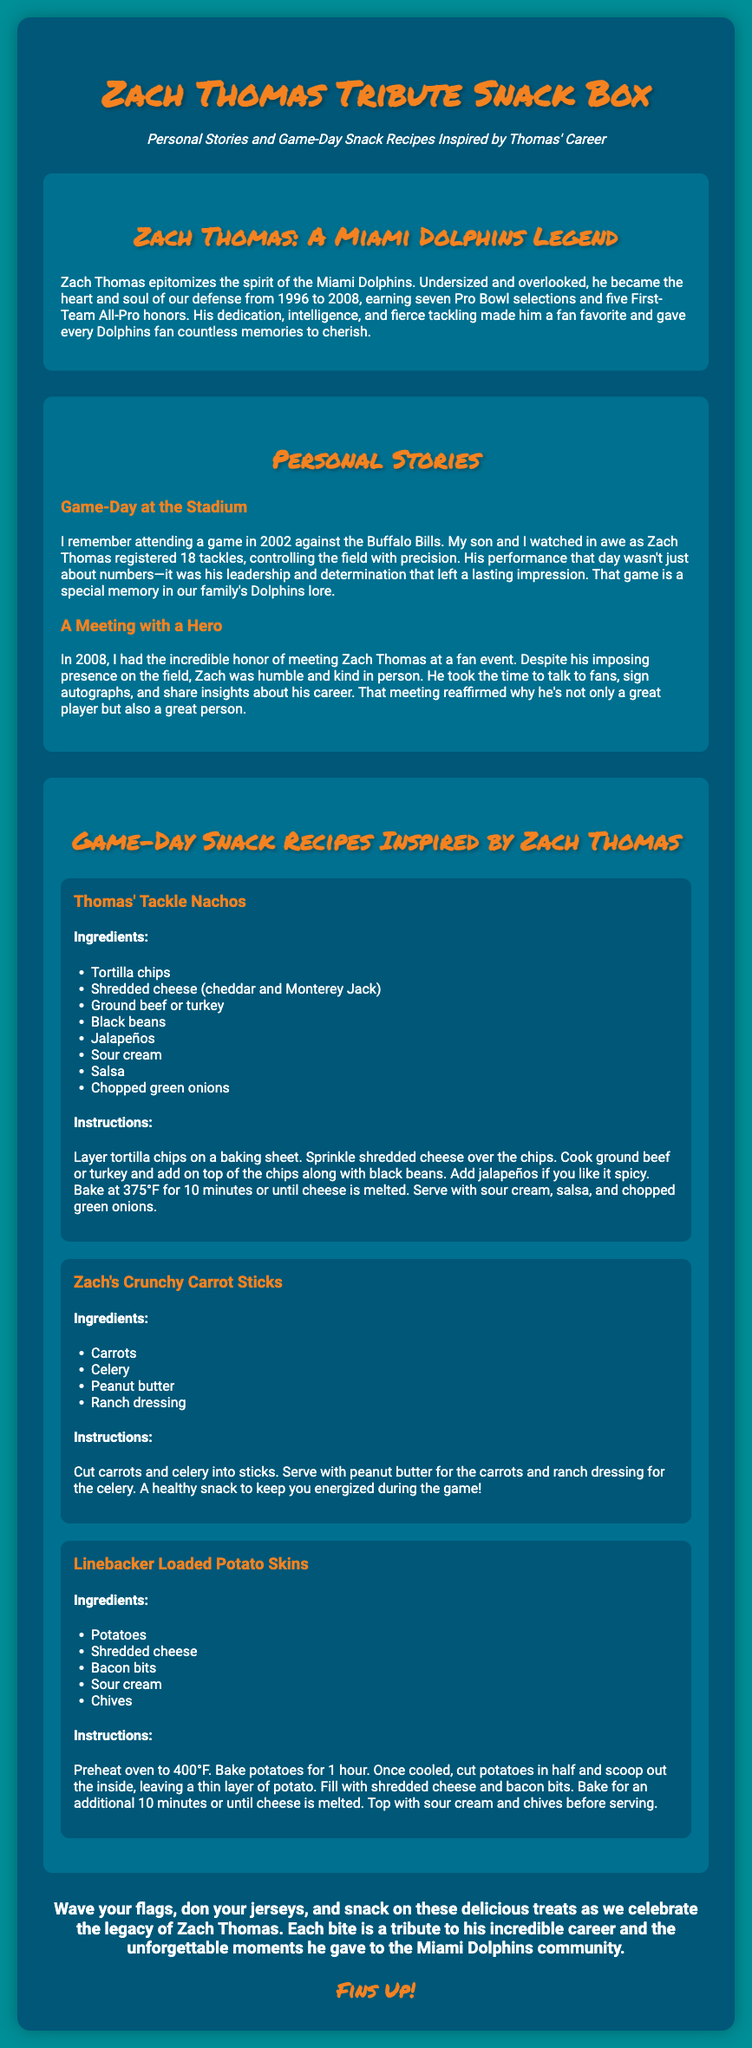What years did Zach Thomas play for the Miami Dolphins? Zach Thomas played for the Miami Dolphins from 1996 to 2008.
Answer: 1996 to 2008 How many Pro Bowl selections did Zach Thomas earn? Zach Thomas earned seven Pro Bowl selections as stated in the document.
Answer: Seven What is the title of the first snack recipe? The title of the first snack recipe mentioned in the document is "Thomas' Tackle Nachos."
Answer: Thomas' Tackle Nachos What memorable game event is described in the personal stories section? The memorable game event described is a game against the Buffalo Bills in 2002 where Zach Thomas registered 18 tackles.
Answer: Game against the Buffalo Bills in 2002 What healthy snack is featured in the snack recipes? The healthy snack featured in the snack recipes is "Zach's Crunchy Carrot Sticks."
Answer: Zach's Crunchy Carrot Sticks What phrase is used to encourage celebration in the document? The phrase encouraging celebration in the document is "Fins Up!"
Answer: Fins Up! How many ingredients are listed for the Loaded Potato Skins recipe? The Loaded Potato Skins recipe lists five ingredients.
Answer: Five What color is the background of the document? The background color of the document is #008E97.
Answer: #008E97 